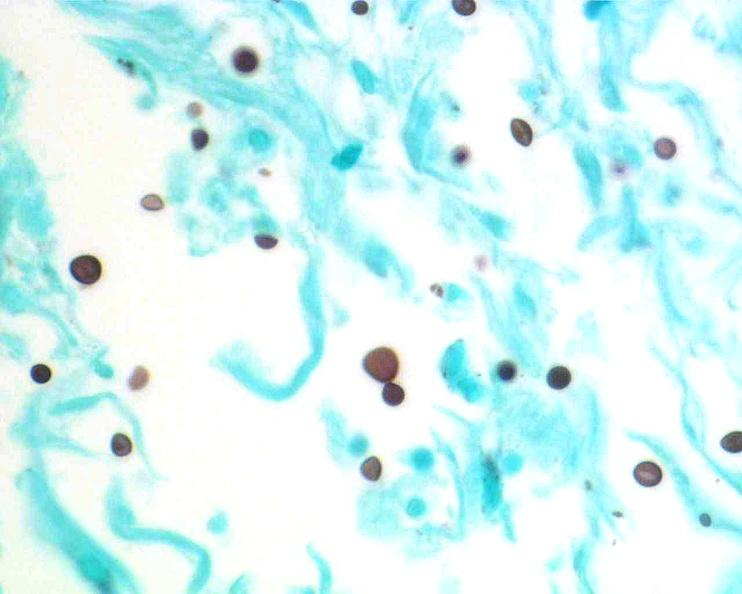s nervous present?
Answer the question using a single word or phrase. Yes 